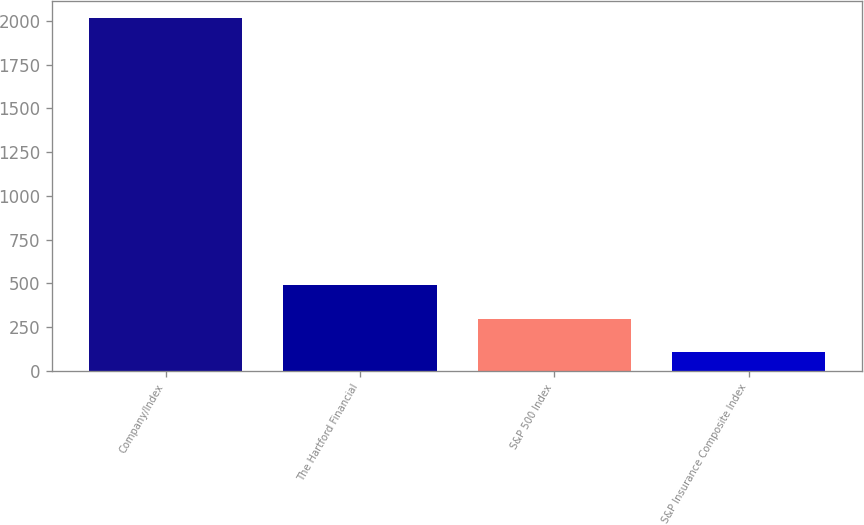Convert chart to OTSL. <chart><loc_0><loc_0><loc_500><loc_500><bar_chart><fcel>Company/Index<fcel>The Hartford Financial<fcel>S&P 500 Index<fcel>S&P Insurance Composite Index<nl><fcel>2014<fcel>489.43<fcel>298.86<fcel>108.29<nl></chart> 